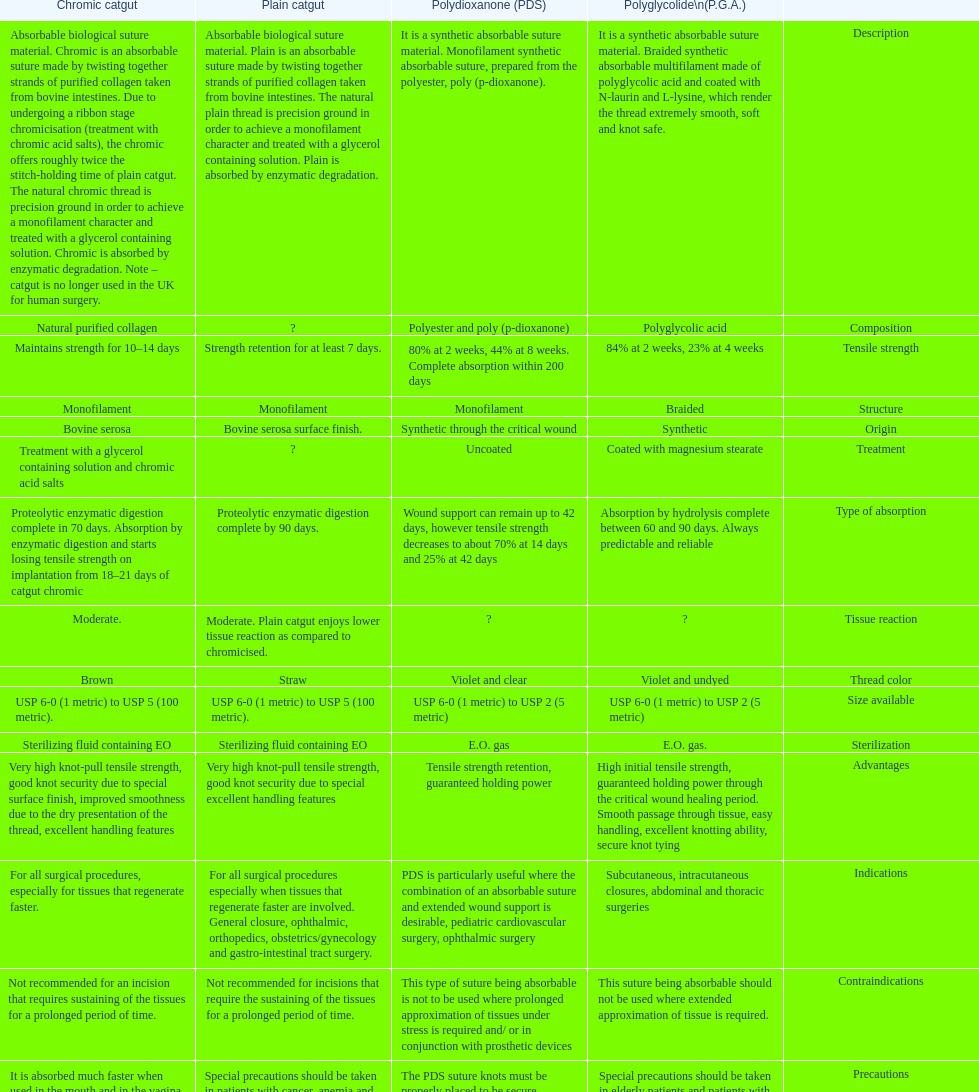What is the structure other than monofilament Braided. 